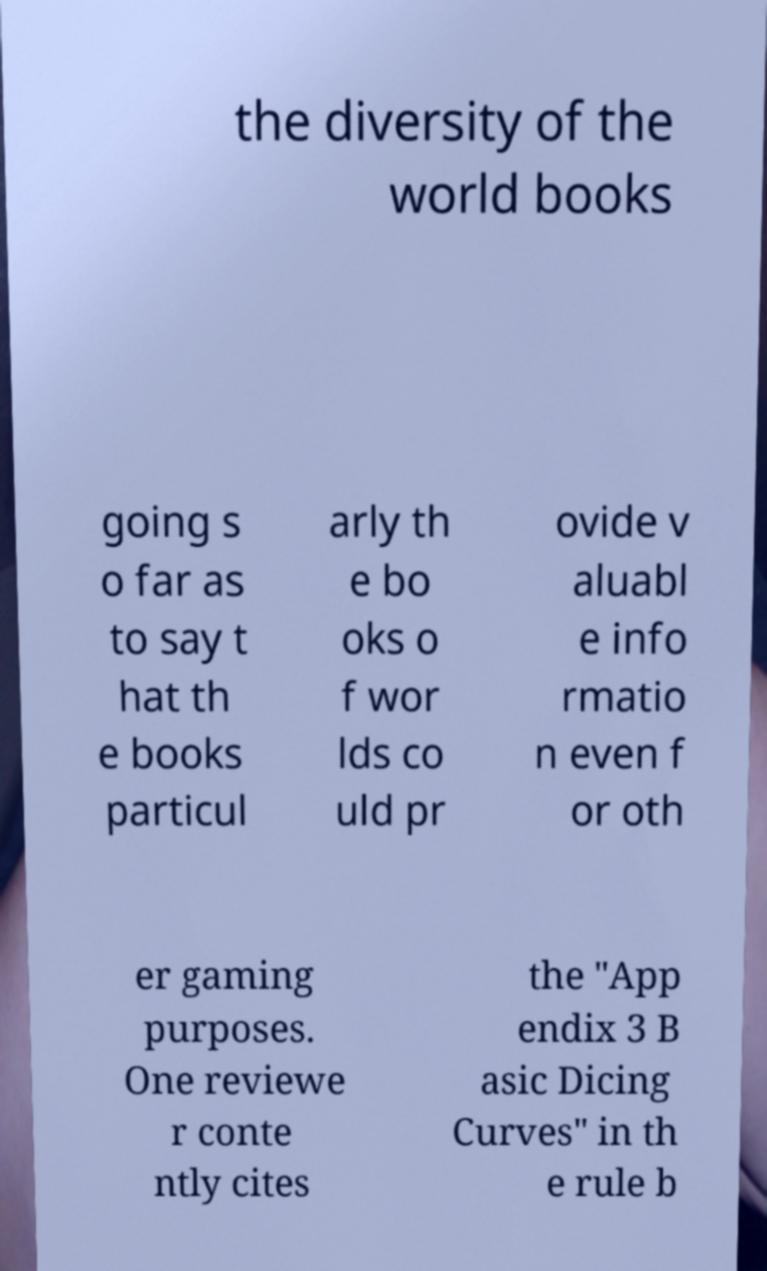Can you accurately transcribe the text from the provided image for me? the diversity of the world books going s o far as to say t hat th e books particul arly th e bo oks o f wor lds co uld pr ovide v aluabl e info rmatio n even f or oth er gaming purposes. One reviewe r conte ntly cites the "App endix 3 B asic Dicing Curves" in th e rule b 